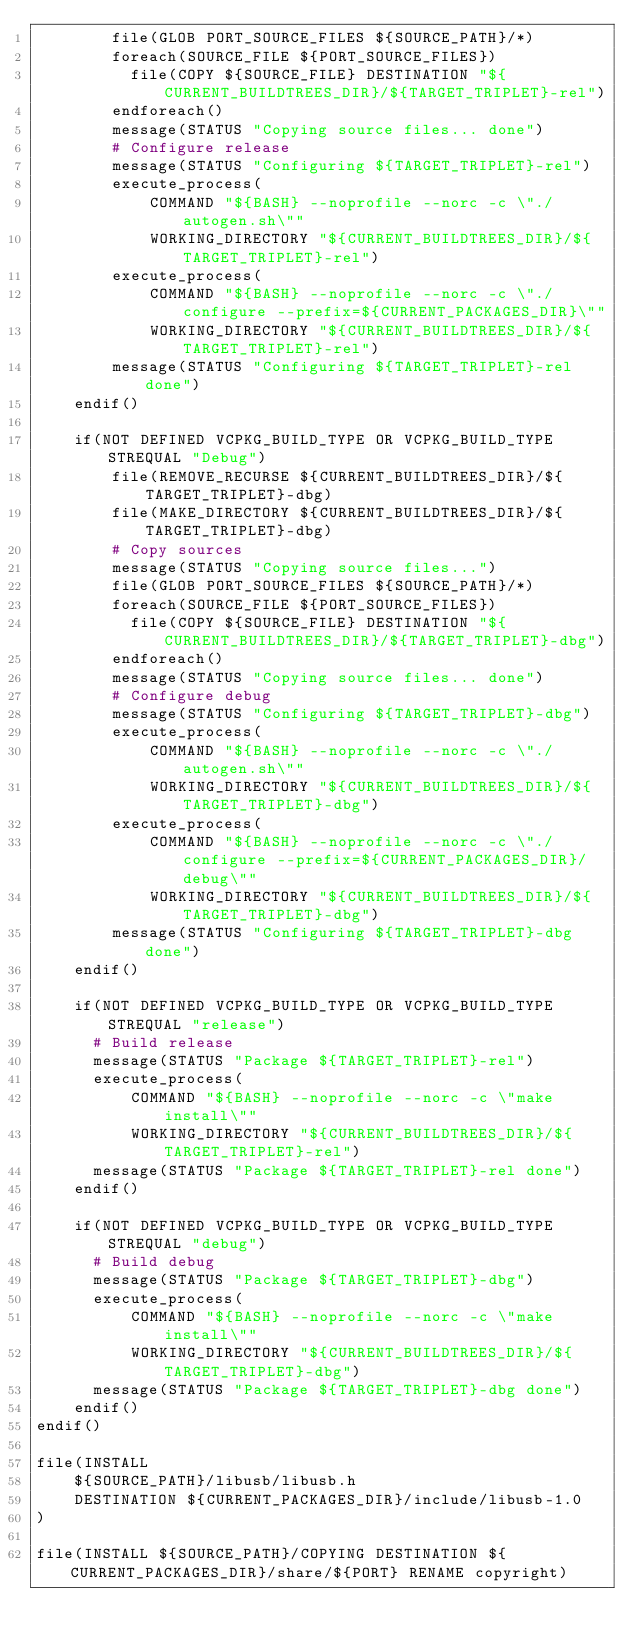<code> <loc_0><loc_0><loc_500><loc_500><_CMake_>        file(GLOB PORT_SOURCE_FILES ${SOURCE_PATH}/*)
        foreach(SOURCE_FILE ${PORT_SOURCE_FILES})
          file(COPY ${SOURCE_FILE} DESTINATION "${CURRENT_BUILDTREES_DIR}/${TARGET_TRIPLET}-rel")
        endforeach()
        message(STATUS "Copying source files... done")
        # Configure release
        message(STATUS "Configuring ${TARGET_TRIPLET}-rel")
        execute_process(
            COMMAND "${BASH} --noprofile --norc -c \"./autogen.sh\""
            WORKING_DIRECTORY "${CURRENT_BUILDTREES_DIR}/${TARGET_TRIPLET}-rel")
        execute_process(
            COMMAND "${BASH} --noprofile --norc -c \"./configure --prefix=${CURRENT_PACKAGES_DIR}\""
            WORKING_DIRECTORY "${CURRENT_BUILDTREES_DIR}/${TARGET_TRIPLET}-rel")
        message(STATUS "Configuring ${TARGET_TRIPLET}-rel done")
    endif()

    if(NOT DEFINED VCPKG_BUILD_TYPE OR VCPKG_BUILD_TYPE STREQUAL "Debug")
        file(REMOVE_RECURSE ${CURRENT_BUILDTREES_DIR}/${TARGET_TRIPLET}-dbg)
        file(MAKE_DIRECTORY ${CURRENT_BUILDTREES_DIR}/${TARGET_TRIPLET}-dbg)
        # Copy sources
        message(STATUS "Copying source files...")
        file(GLOB PORT_SOURCE_FILES ${SOURCE_PATH}/*)
        foreach(SOURCE_FILE ${PORT_SOURCE_FILES})
          file(COPY ${SOURCE_FILE} DESTINATION "${CURRENT_BUILDTREES_DIR}/${TARGET_TRIPLET}-dbg")
        endforeach()
        message(STATUS "Copying source files... done")
        # Configure debug
        message(STATUS "Configuring ${TARGET_TRIPLET}-dbg")
        execute_process(
            COMMAND "${BASH} --noprofile --norc -c \"./autogen.sh\""
            WORKING_DIRECTORY "${CURRENT_BUILDTREES_DIR}/${TARGET_TRIPLET}-dbg")
        execute_process(
            COMMAND "${BASH} --noprofile --norc -c \"./configure --prefix=${CURRENT_PACKAGES_DIR}/debug\""
            WORKING_DIRECTORY "${CURRENT_BUILDTREES_DIR}/${TARGET_TRIPLET}-dbg")
        message(STATUS "Configuring ${TARGET_TRIPLET}-dbg done")
    endif()

    if(NOT DEFINED VCPKG_BUILD_TYPE OR VCPKG_BUILD_TYPE STREQUAL "release")
      # Build release
      message(STATUS "Package ${TARGET_TRIPLET}-rel")
      execute_process(
          COMMAND "${BASH} --noprofile --norc -c \"make install\""
          WORKING_DIRECTORY "${CURRENT_BUILDTREES_DIR}/${TARGET_TRIPLET}-rel")
      message(STATUS "Package ${TARGET_TRIPLET}-rel done")
    endif()

    if(NOT DEFINED VCPKG_BUILD_TYPE OR VCPKG_BUILD_TYPE STREQUAL "debug")
      # Build debug
      message(STATUS "Package ${TARGET_TRIPLET}-dbg")
      execute_process(
          COMMAND "${BASH} --noprofile --norc -c \"make install\""
          WORKING_DIRECTORY "${CURRENT_BUILDTREES_DIR}/${TARGET_TRIPLET}-dbg")
      message(STATUS "Package ${TARGET_TRIPLET}-dbg done")
    endif()
endif()

file(INSTALL
    ${SOURCE_PATH}/libusb/libusb.h
    DESTINATION ${CURRENT_PACKAGES_DIR}/include/libusb-1.0
)

file(INSTALL ${SOURCE_PATH}/COPYING DESTINATION ${CURRENT_PACKAGES_DIR}/share/${PORT} RENAME copyright)
</code> 